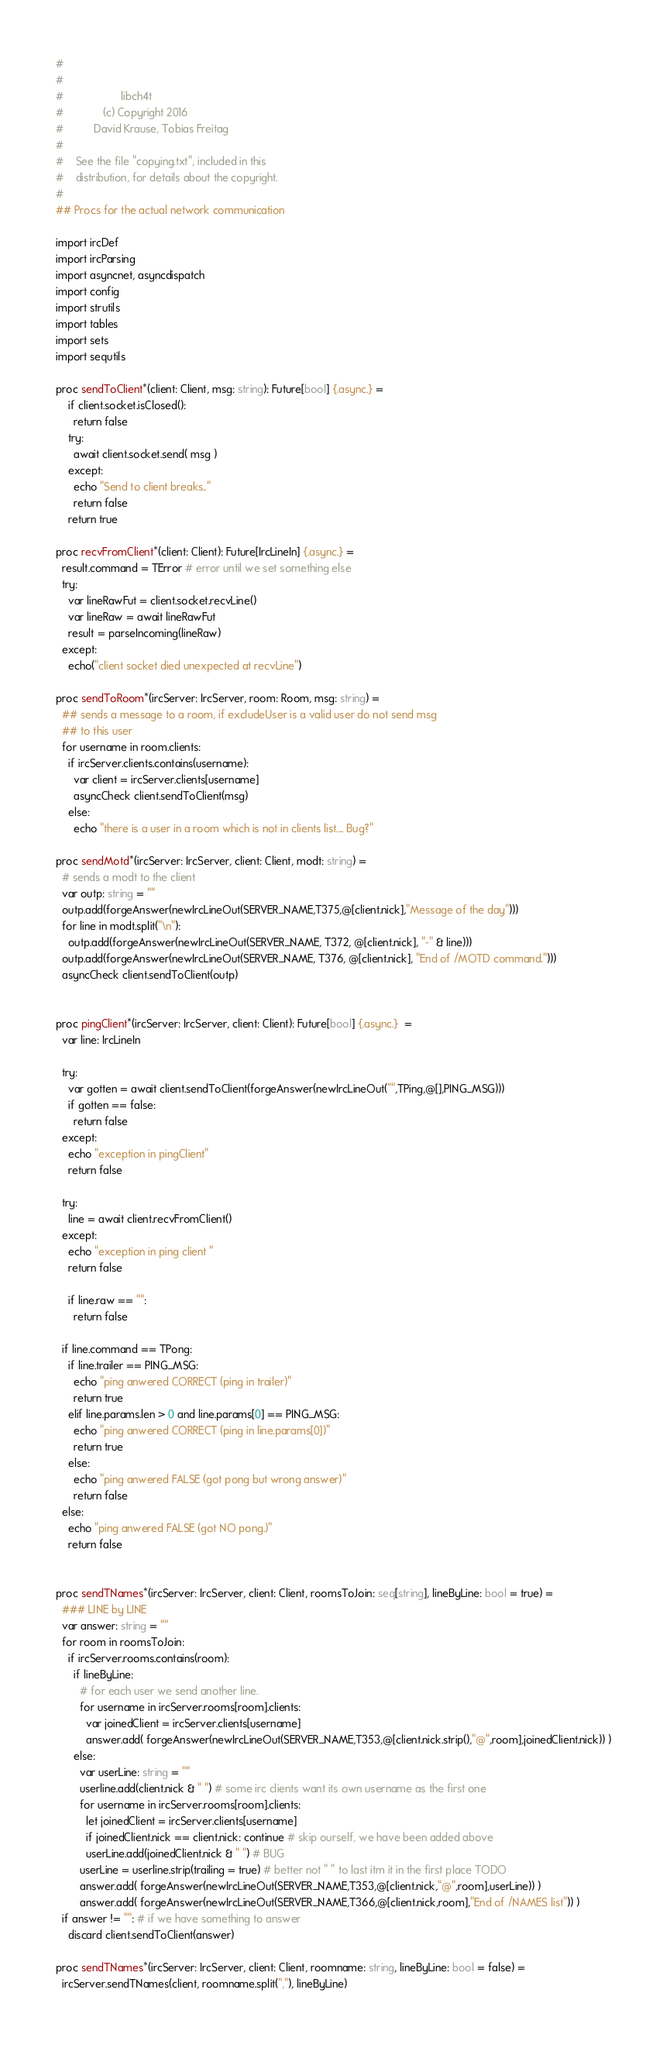Convert code to text. <code><loc_0><loc_0><loc_500><loc_500><_Nim_>#
#
#                   libch4t 
#             (c) Copyright 2016 
#          David Krause, Tobias Freitag
#
#    See the file "copying.txt", included in this
#    distribution, for details about the copyright.
#
## Procs for the actual network communication

import ircDef
import ircParsing
import asyncnet, asyncdispatch
import config
import strutils
import tables
import sets
import sequtils

proc sendToClient*(client: Client, msg: string): Future[bool] {.async.} =
    if client.socket.isClosed():
      return false
    try:
      await client.socket.send( msg )
    except:
      echo "Send to client breaks.."
      return false
    return true      

proc recvFromClient*(client: Client): Future[IrcLineIn] {.async.} = 
  result.command = TError # error until we set something else
  try:
    var lineRawFut = client.socket.recvLine()
    var lineRaw = await lineRawFut
    result = parseIncoming(lineRaw)
  except:
    echo("client socket died unexpected at recvLine")

proc sendToRoom*(ircServer: IrcServer, room: Room, msg: string) =
  ## sends a message to a room, if excludeUser is a valid user do not send msg 
  ## to this user
  for username in room.clients:
    if ircServer.clients.contains(username):
      var client = ircServer.clients[username]
      asyncCheck client.sendToClient(msg)
    else:
      echo "there is a user in a room which is not in clients list.... Bug?"

proc sendMotd*(ircServer: IrcServer, client: Client, modt: string) =
  # sends a modt to the client
  var outp: string = ""
  outp.add(forgeAnswer(newIrcLineOut(SERVER_NAME,T375,@[client.nick],"Message of the day")))
  for line in modt.split("\n"):
    outp.add(forgeAnswer(newIrcLineOut(SERVER_NAME, T372, @[client.nick], "-" & line)))
  outp.add(forgeAnswer(newIrcLineOut(SERVER_NAME, T376, @[client.nick], "End of /MOTD command.")))
  asyncCheck client.sendToClient(outp)


proc pingClient*(ircServer: IrcServer, client: Client): Future[bool] {.async.}  =
  var line: IrcLineIn

  try:
    var gotten = await client.sendToClient(forgeAnswer(newIrcLineOut("",TPing,@[],PING_MSG)))
    if gotten == false:
      return false
  except:
    echo "exception in pingClient"
    return false

  try:
    line = await client.recvFromClient()
  except:
    echo "exception in ping client "
    return false

    if line.raw == "":
      return false

  if line.command == TPong:
    if line.trailer == PING_MSG:
      echo "ping anwered CORRECT (ping in trailer)"
      return true
    elif line.params.len > 0 and line.params[0] == PING_MSG:
      echo "ping anwered CORRECT (ping in line.params[0])"
      return true
    else:
      echo "ping anwered FALSE (got pong but wrong answer)"
      return false
  else:
    echo "ping anwered FALSE (got NO pong.)"
    return false    
    

proc sendTNames*(ircServer: IrcServer, client: Client, roomsToJoin: seq[string], lineByLine: bool = true) =
  ### LINE by LINE
  var answer: string = ""
  for room in roomsToJoin:
    if ircServer.rooms.contains(room):
      if lineByLine:
        # for each user we send another line.
        for username in ircServer.rooms[room].clients:
          var joinedClient = ircServer.clients[username]
          answer.add( forgeAnswer(newIrcLineOut(SERVER_NAME,T353,@[client.nick.strip(),"@",room],joinedClient.nick)) )
      else:
        var userLine: string = ""
        userline.add(client.nick & " ") # some irc clients want its own username as the first one
        for username in ircServer.rooms[room].clients:
          let joinedClient = ircServer.clients[username] 
          if joinedClient.nick == client.nick: continue # skip ourself, we have been added above
          userLine.add(joinedClient.nick & " ") # BUG 
        userLine = userline.strip(trailing = true) # better not " " to last itm it in the first place TODO
        answer.add( forgeAnswer(newIrcLineOut(SERVER_NAME,T353,@[client.nick,"@",room],userLine)) )
        answer.add( forgeAnswer(newIrcLineOut(SERVER_NAME,T366,@[client.nick,room],"End of /NAMES list")) )
  if answer != "": # if we have something to answer
    discard client.sendToClient(answer)

proc sendTNames*(ircServer: IrcServer, client: Client, roomname: string, lineByLine: bool = false) =
  ircServer.sendTNames(client, roomname.split(","), lineByLine)

</code> 